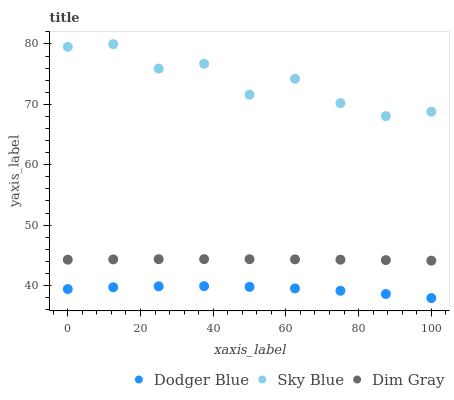Does Dodger Blue have the minimum area under the curve?
Answer yes or no. Yes. Does Sky Blue have the maximum area under the curve?
Answer yes or no. Yes. Does Dim Gray have the minimum area under the curve?
Answer yes or no. No. Does Dim Gray have the maximum area under the curve?
Answer yes or no. No. Is Dim Gray the smoothest?
Answer yes or no. Yes. Is Sky Blue the roughest?
Answer yes or no. Yes. Is Dodger Blue the smoothest?
Answer yes or no. No. Is Dodger Blue the roughest?
Answer yes or no. No. Does Dodger Blue have the lowest value?
Answer yes or no. Yes. Does Dim Gray have the lowest value?
Answer yes or no. No. Does Sky Blue have the highest value?
Answer yes or no. Yes. Does Dim Gray have the highest value?
Answer yes or no. No. Is Dodger Blue less than Dim Gray?
Answer yes or no. Yes. Is Sky Blue greater than Dodger Blue?
Answer yes or no. Yes. Does Dodger Blue intersect Dim Gray?
Answer yes or no. No. 